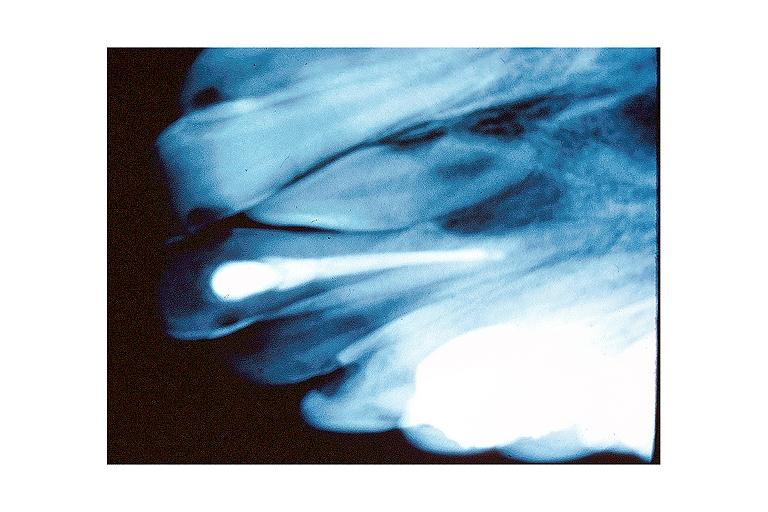does this image show mesiodens?
Answer the question using a single word or phrase. Yes 